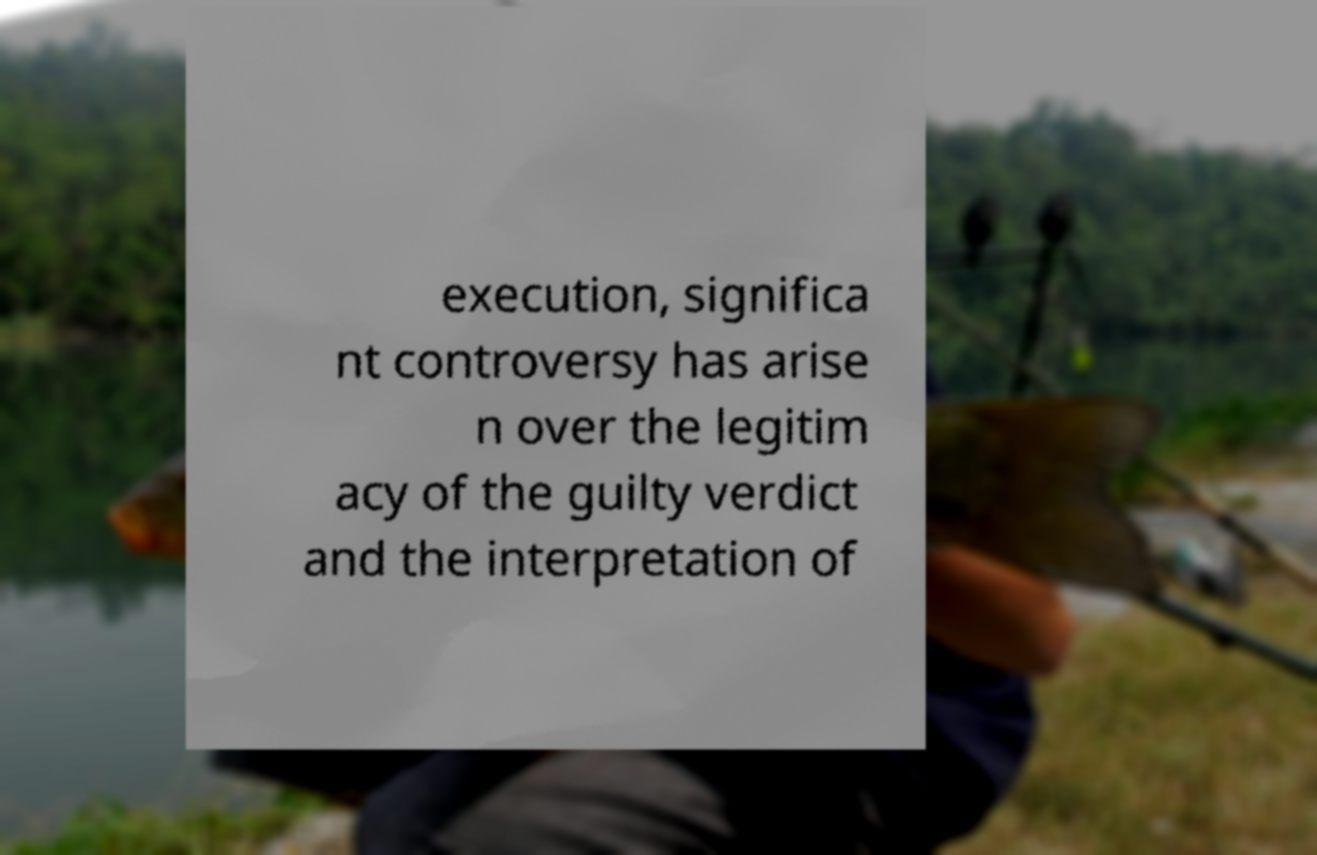For documentation purposes, I need the text within this image transcribed. Could you provide that? execution, significa nt controversy has arise n over the legitim acy of the guilty verdict and the interpretation of 